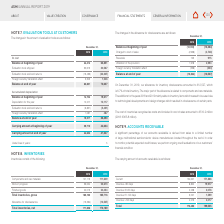According to Asm International Nv's financial document, What does the table show? changes in the allowance for obsolescence. The document states: "The changes in the allowance for obsolescence are as follows:..." Also, What is the major part of the obsolescence allowance? components and raw materials. The document states: "Components and raw materials 127,113 111,609..." Also, What was the Balance at beginning of year 2019? According to the financial document, (13,364). The relevant text states: "Balance at beginning of year (12,749) (13,364)..." Also, can you calculate: What is the percentage change in Balance at end of year from 2018 to 2019? To answer this question, I need to perform calculations using the financial data. The calculation is: ( -12,527 - (-13,364))/-13,364, which equals -6.26 (percentage). This is based on the information: "Balance at end of year (13,364) (12,527) Balance at end of year (13,364) (12,527)..." The key data points involved are: 12,527, 13,364. Additionally, Which component caused the greatest increase in allowance for inventory obsolescence in 2019? Charged to cost of sales. The document states: "Charged to cost of sales (2,958) (4,748)..." Also, can you calculate: What is the change in reversals from 2018 to 2019? Based on the calculation: 915-723, the result is 192. This is based on the information: "Reversals 723 915 Reversals 723 915..." The key data points involved are: 723, 915. 